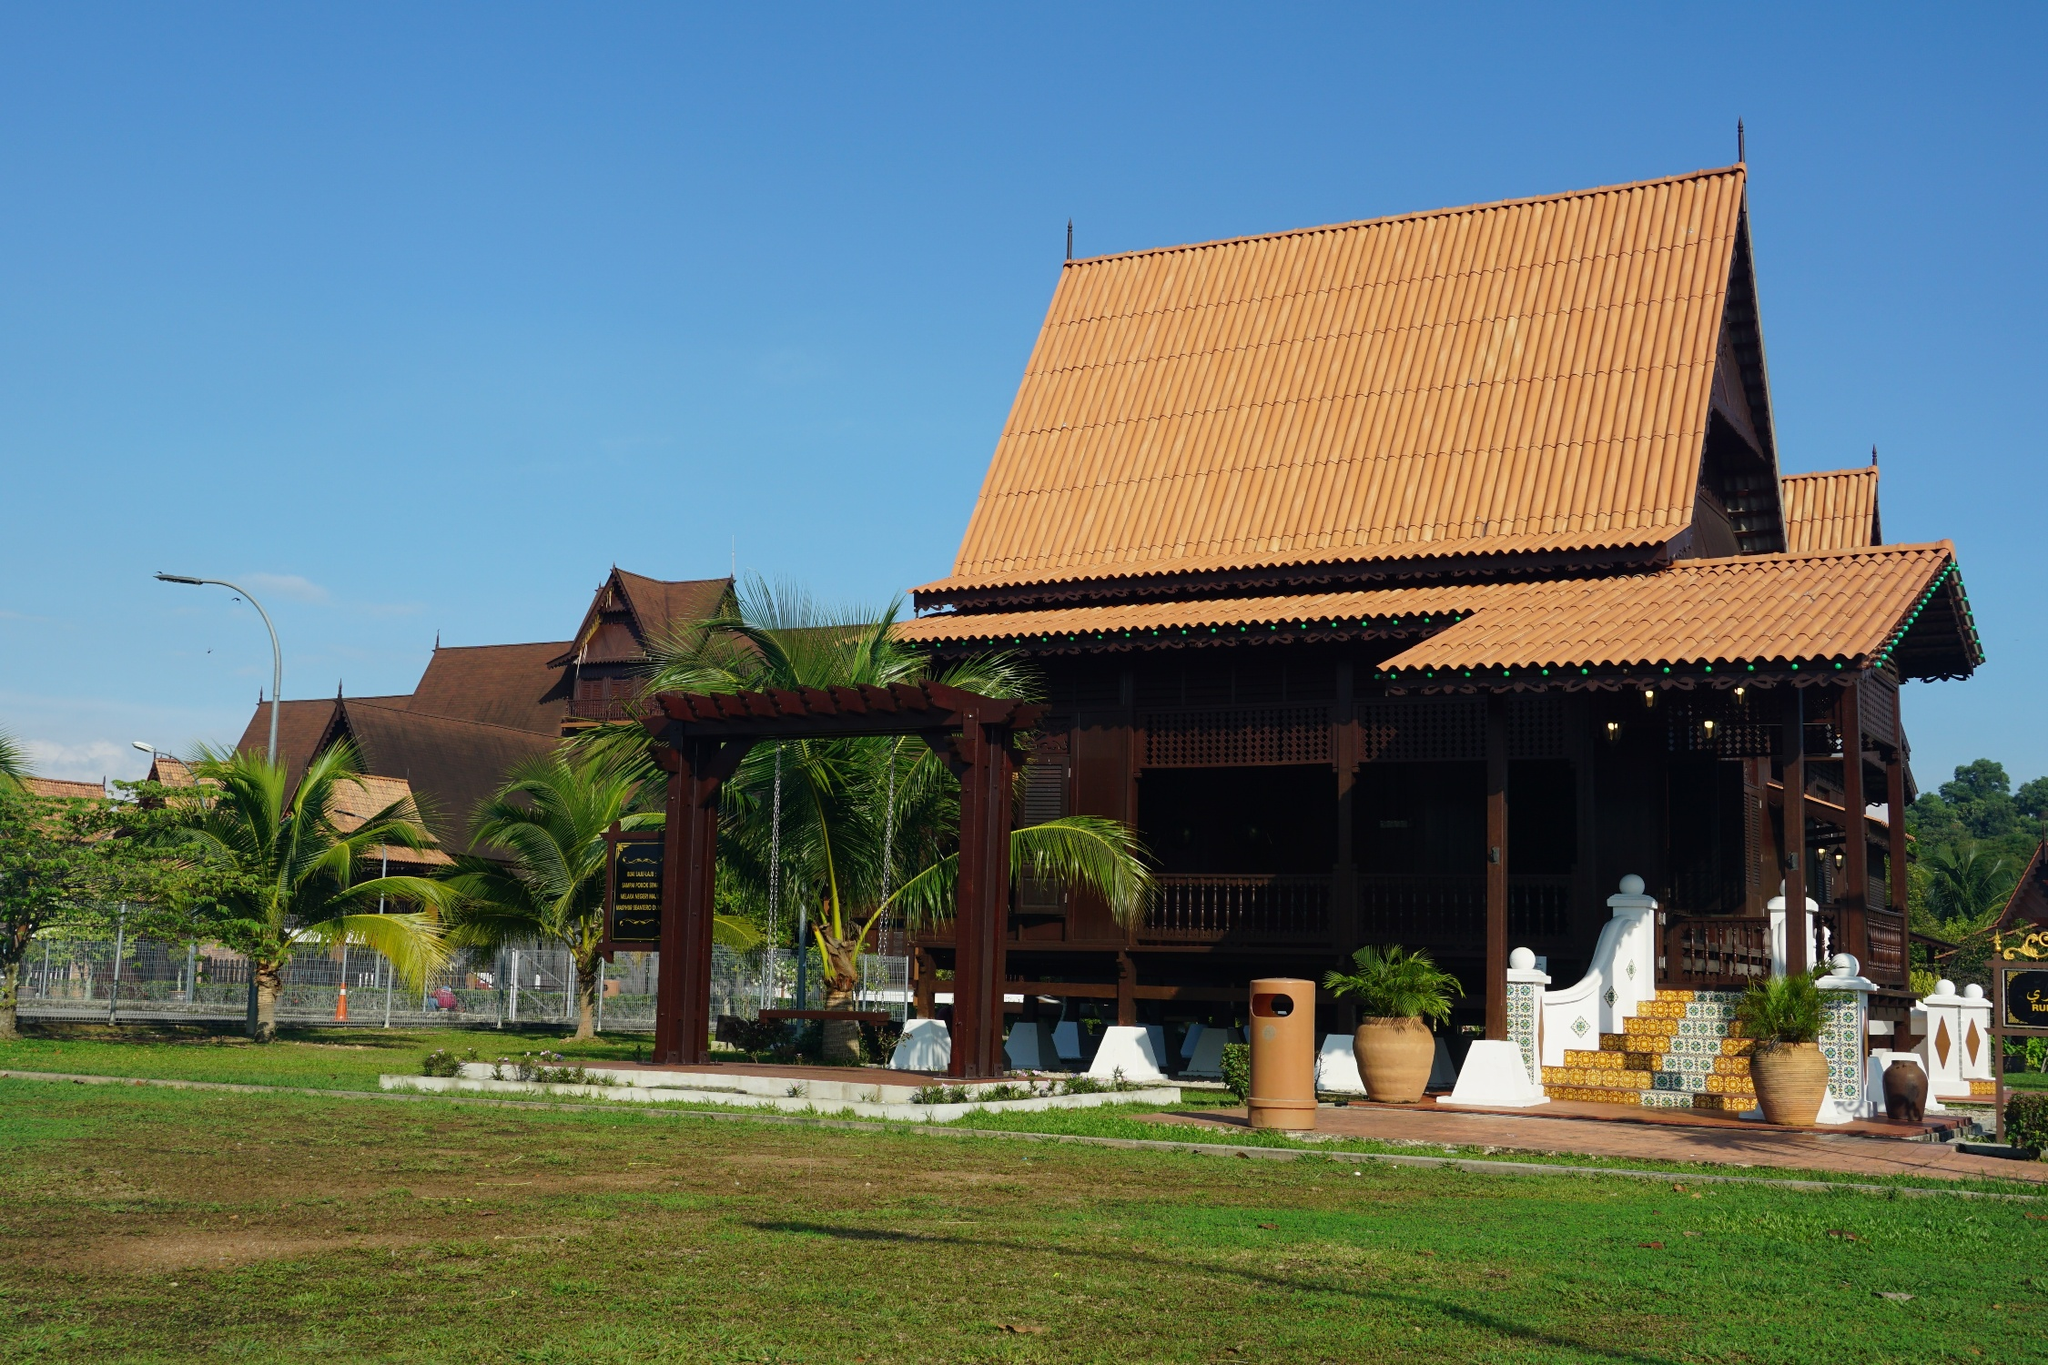Compare this type of house to modern architecture in urban cities. Traditional Thai houses, like the one in the image, differ significantly from modern urban architecture in several aspects. Thai houses typically feature elevated structures, steeply pitched roofs, and intricate wooden details, drawing heavily from cultural and environmental considerations. These houses are designed to harmonize with their natural surroundings, using local materials and techniques.

In contrast, modern urban architecture often emphasizes function and efficiency, featuring sleek lines, minimalistic design, and the use of advanced materials like glass, steel, and concrete. Modern buildings prioritize space optimization, energy efficiency, and integration of technology, often resulting in high-rise structures densely packed in urban environments.

While modern architecture focuses on contemporary needs and aesthetics, traditional Thai houses reflect a deep connection to cultural heritage and environmental adaptations. Both styles offer unique advantages, representing different approaches to design and living. Imagine a fantasy world where this house transforms at night. What happens? Picture a magical transformation where, as night falls, the house comes alive with a mystical glow. The red-tiled roof begins to shimmer like a sunset, casting a warm, golden light that illuminates the surroundings. Lanterns, twisted with vines of luminescent flowers, float gently around the house, bathing the area in a soft, ethereal light. The intricate wooden carvings start to move, depicting scenes from ancient legends, their stories unfolding in a mesmerizing dance of shadows and light.

The palm trees around the house sway to the rhythm of an otherworldly melody, their fronds twinkling with thousands of tiny star-like lights. The lawn transforms into a magical meadow, with bioluminescent plants illuminating the path. Creatures of folklore, like ethereal spirits and mythical animals, emerge to celebrate under the celestial canopy, weaving tales of wonder and enchantment throughout the night. In this fantasy world, the house is more than a shelter—it's a gateway to another realm, where magic and reality intertwine. 